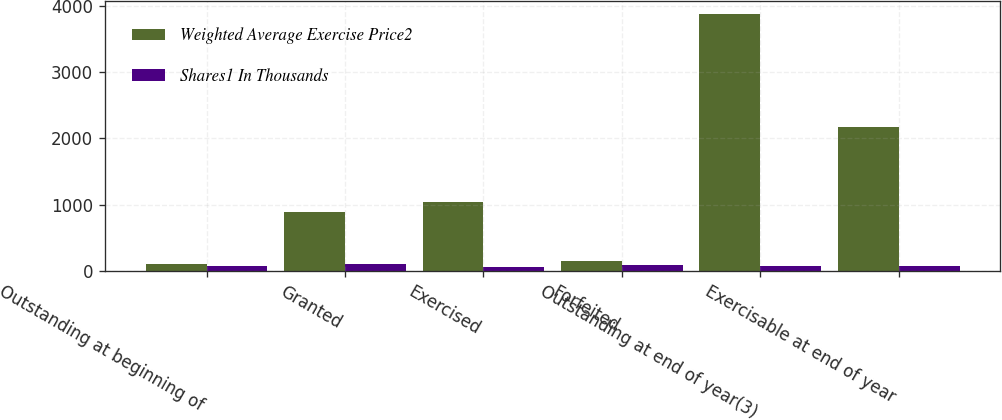Convert chart to OTSL. <chart><loc_0><loc_0><loc_500><loc_500><stacked_bar_chart><ecel><fcel>Outstanding at beginning of<fcel>Granted<fcel>Exercised<fcel>Forfeited<fcel>Outstanding at end of year(3)<fcel>Exercisable at end of year<nl><fcel>Weighted Average Exercise Price2<fcel>100<fcel>894<fcel>1045<fcel>152<fcel>3878<fcel>2171<nl><fcel>Shares1 In Thousands<fcel>71<fcel>100<fcel>59<fcel>91<fcel>79<fcel>70<nl></chart> 